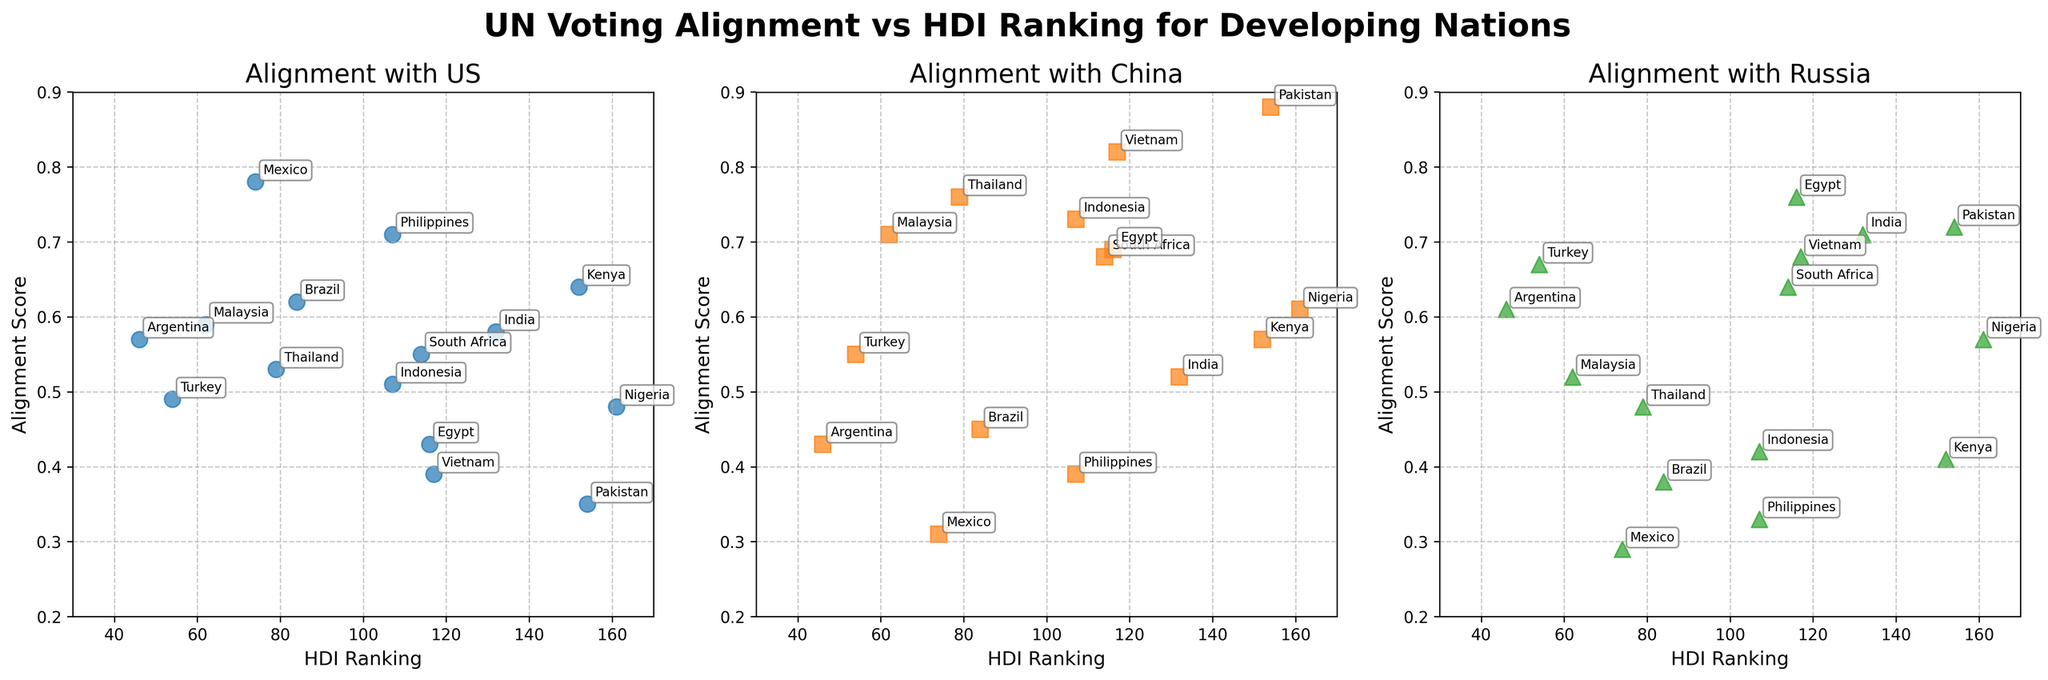What is the title of the figure? The title is located at the top center of the figure, presented in bold and large font size. It reads "UN Voting Alignment vs HDI Ranking for Developing Nations."
Answer: UN Voting Alignment vs HDI Ranking for Developing Nations What is the range of the x-axis? The x-axis represents the HDI Ranking and it ranges from 30 to 170 as shown by the axis limits.
Answer: 30 to 170 Which country has the highest alignment score with the United States? By observing the scatter plot for the United States alignment, you can see that Mexico has the highest alignment score, positioned at 0.78.
Answer: Mexico How does the alignment with China correlate with HDI rankings in general? By examining the scatter plot for China's alignment, it appears that higher HDI rankings (lower numbers) are often associated with lower alignment scores, while lower HDI rankings (higher numbers) generally have higher alignment scores.
Answer: Negative correlation Which country has the lowest alignment with Russia? Pakistan has the lowest alignment score with Russia, positioned at 0.33.
Answer: Philippines Is there any country that has a higher alignment score with China than with Russia? By comparing the alignment scores for each country, Vietnam has a higher alignment score with China (0.82) compared to Russia (0.68).
Answer: Vietnam What is the alignment score range for countries with HDI rankings between 80 and 120 with the US? Countries within HDI rankings 80-120 have alignment with the US ranging approximately between 0.35 (Egypt) and 0.62 (Brazil).
Answer: 0.35 to 0.62 Which power shows the highest alignment score for India? India has the highest alignment score with Russia, positioned at 0.71, compared to the United States (0.58) and China (0.52).
Answer: Russia Identify a country with nearly equal alignment scores with both the US and Russia. Turkey has nearly equal alignment scores, with 0.49 for the US and 0.67 for Russia.
Answer: Turkey What general trend can you observe in the alignment with Russia vs HDI ranking? Upon examining the scatter plot for Russia's alignment, there is a general trend where countries with lower HDI rankings tend to have higher alignment scores, indicating a trend of higher alignment scores with decreasing HDI rankings.
Answer: Lower HDI, higher alignment 